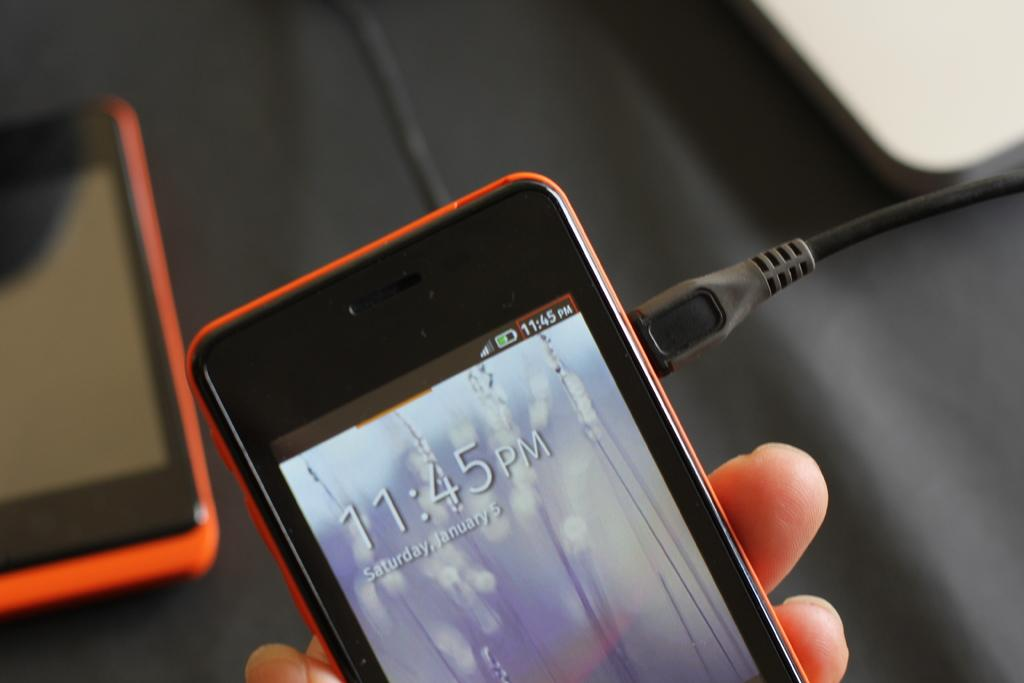<image>
Offer a succinct explanation of the picture presented. hand holding plugged in orange cellphone showing time of 11:45 pm on saturday, january 5 